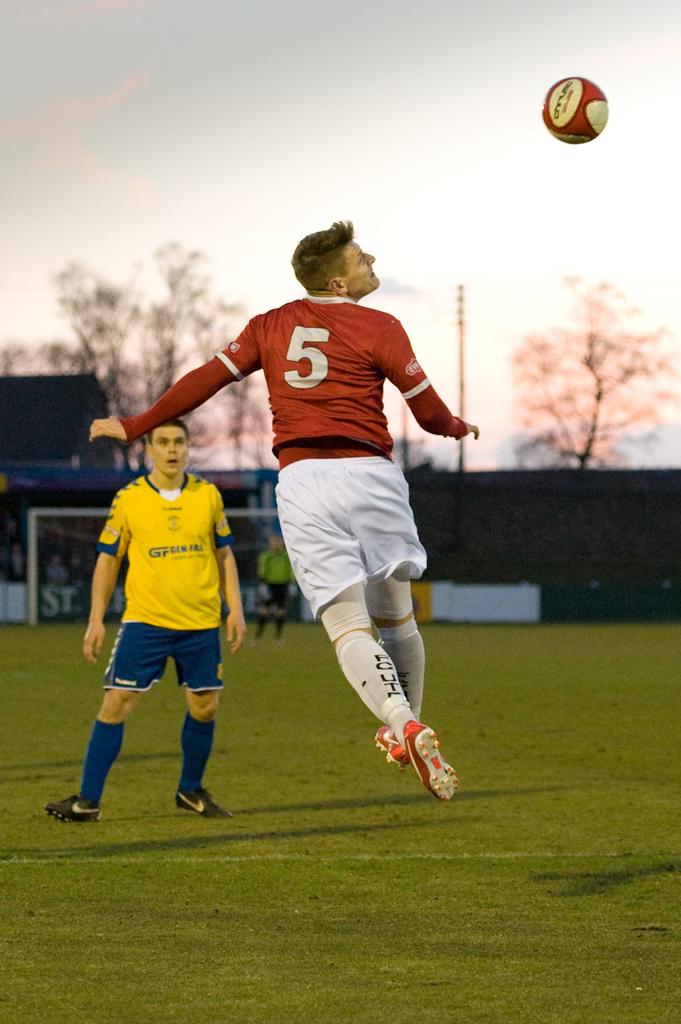What is the number of the red jersey?
Provide a succinct answer. 5. What number is on the red shirt?
Your answer should be compact. 5. 